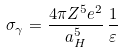Convert formula to latex. <formula><loc_0><loc_0><loc_500><loc_500>\sigma _ { \gamma } = \frac { 4 \pi Z ^ { 5 } e ^ { 2 } } { a _ { H } ^ { 5 } } \, \frac { 1 } { \varepsilon }</formula> 